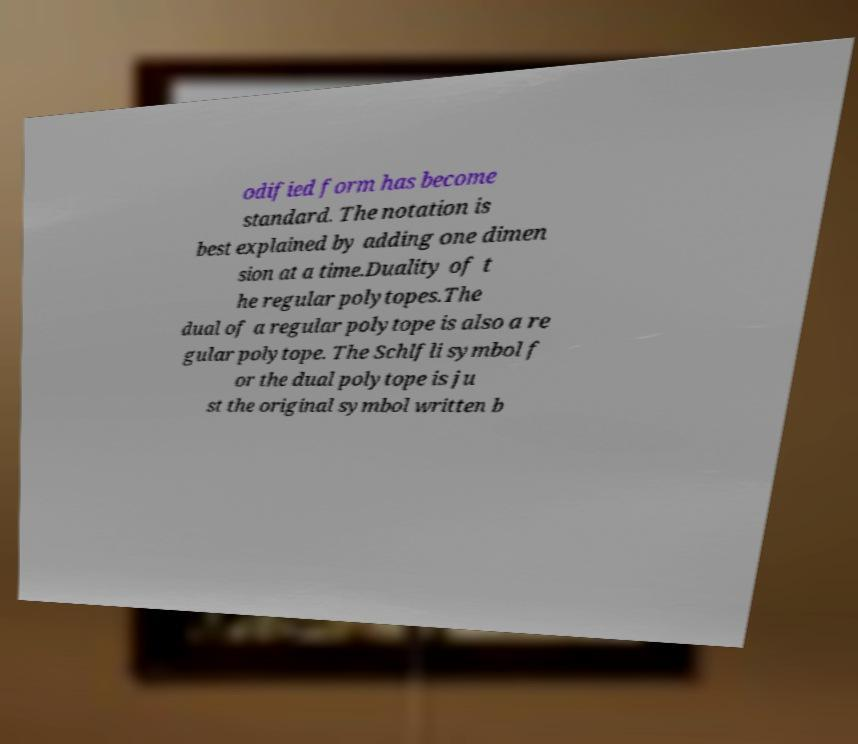For documentation purposes, I need the text within this image transcribed. Could you provide that? odified form has become standard. The notation is best explained by adding one dimen sion at a time.Duality of t he regular polytopes.The dual of a regular polytope is also a re gular polytope. The Schlfli symbol f or the dual polytope is ju st the original symbol written b 